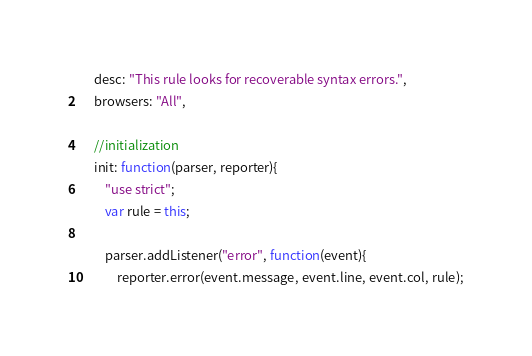Convert code to text. <code><loc_0><loc_0><loc_500><loc_500><_JavaScript_>    desc: "This rule looks for recoverable syntax errors.",
    browsers: "All",

    //initialization
    init: function(parser, reporter){
        "use strict";
        var rule = this;

        parser.addListener("error", function(event){
            reporter.error(event.message, event.line, event.col, rule);</code> 